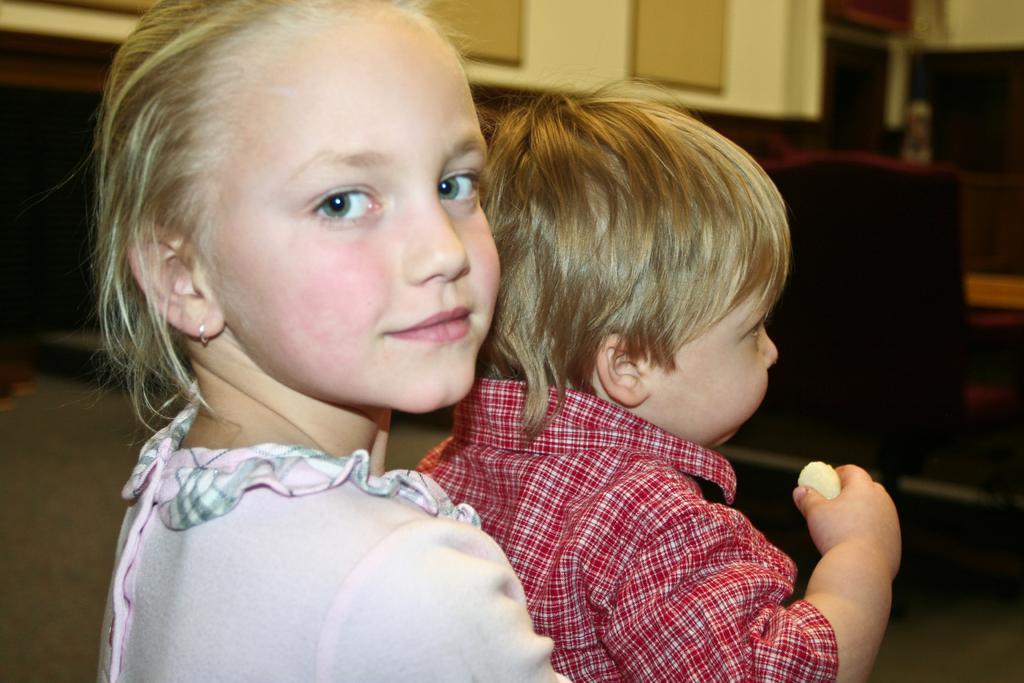Describe this image in one or two sentences. A little cute girl is looking at this side, she wore a pink color dress. There is a little boy, he wore red color shirt. 